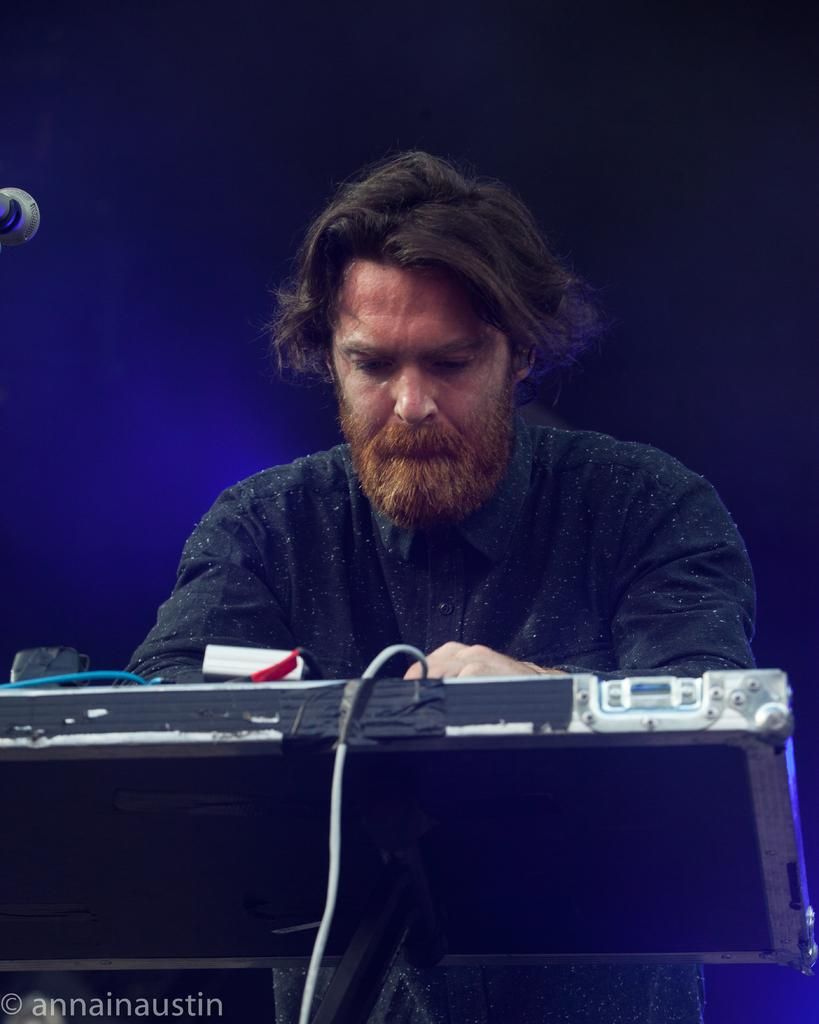Who is the main subject in the foreground of the image? There is a man in the foreground of the image. What is the man standing in front of? The man is standing in front of a musical keyboard. Where is the mic located in the image? The mic is in the left top of the image. What color is the background of the image? The background of the image is blue. What type of garden can be seen in the image? There is no garden present in the image. What role does the minister play in the image? There is no minister present in the image. 